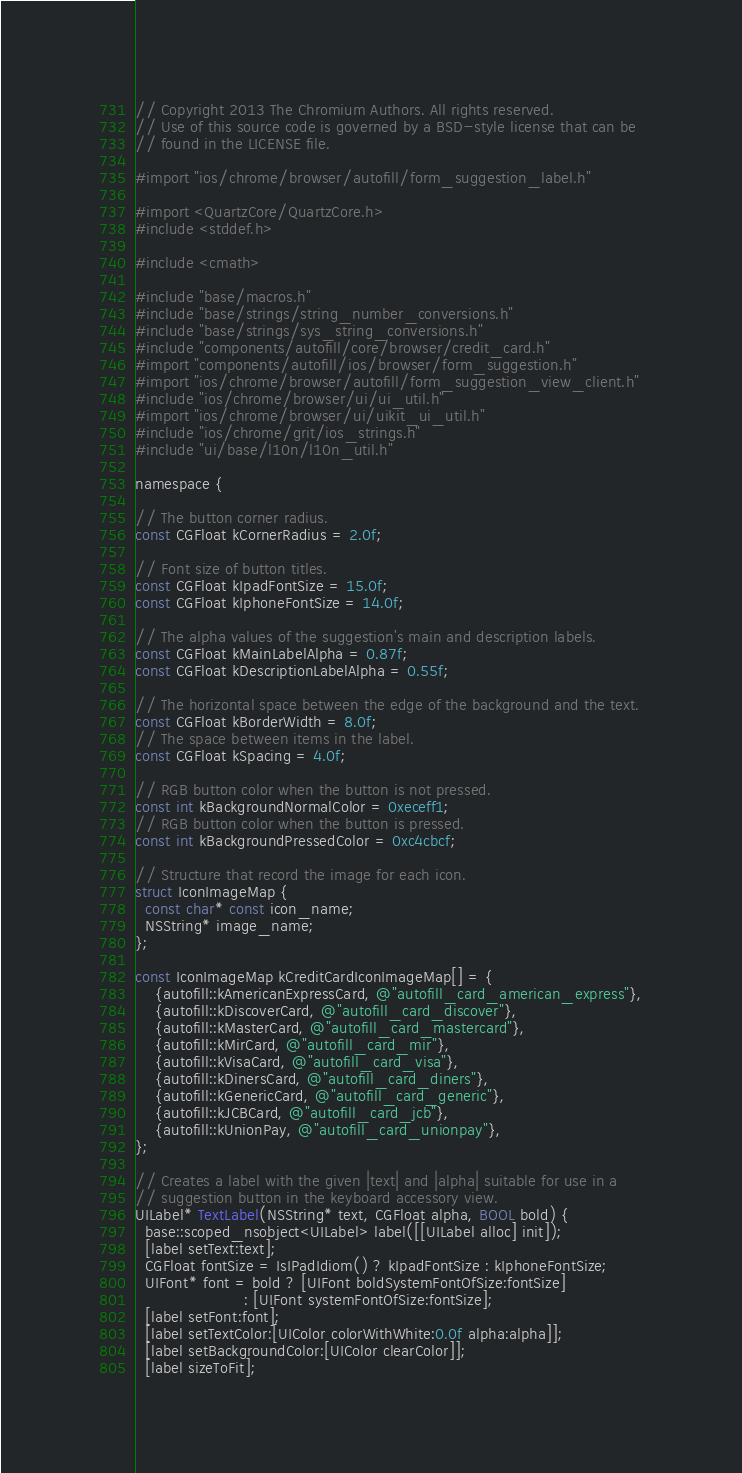<code> <loc_0><loc_0><loc_500><loc_500><_ObjectiveC_>// Copyright 2013 The Chromium Authors. All rights reserved.
// Use of this source code is governed by a BSD-style license that can be
// found in the LICENSE file.

#import "ios/chrome/browser/autofill/form_suggestion_label.h"

#import <QuartzCore/QuartzCore.h>
#include <stddef.h>

#include <cmath>

#include "base/macros.h"
#include "base/strings/string_number_conversions.h"
#include "base/strings/sys_string_conversions.h"
#include "components/autofill/core/browser/credit_card.h"
#import "components/autofill/ios/browser/form_suggestion.h"
#import "ios/chrome/browser/autofill/form_suggestion_view_client.h"
#include "ios/chrome/browser/ui/ui_util.h"
#import "ios/chrome/browser/ui/uikit_ui_util.h"
#include "ios/chrome/grit/ios_strings.h"
#include "ui/base/l10n/l10n_util.h"

namespace {

// The button corner radius.
const CGFloat kCornerRadius = 2.0f;

// Font size of button titles.
const CGFloat kIpadFontSize = 15.0f;
const CGFloat kIphoneFontSize = 14.0f;

// The alpha values of the suggestion's main and description labels.
const CGFloat kMainLabelAlpha = 0.87f;
const CGFloat kDescriptionLabelAlpha = 0.55f;

// The horizontal space between the edge of the background and the text.
const CGFloat kBorderWidth = 8.0f;
// The space between items in the label.
const CGFloat kSpacing = 4.0f;

// RGB button color when the button is not pressed.
const int kBackgroundNormalColor = 0xeceff1;
// RGB button color when the button is pressed.
const int kBackgroundPressedColor = 0xc4cbcf;

// Structure that record the image for each icon.
struct IconImageMap {
  const char* const icon_name;
  NSString* image_name;
};

const IconImageMap kCreditCardIconImageMap[] = {
    {autofill::kAmericanExpressCard, @"autofill_card_american_express"},
    {autofill::kDiscoverCard, @"autofill_card_discover"},
    {autofill::kMasterCard, @"autofill_card_mastercard"},
    {autofill::kMirCard, @"autofill_card_mir"},
    {autofill::kVisaCard, @"autofill_card_visa"},
    {autofill::kDinersCard, @"autofill_card_diners"},
    {autofill::kGenericCard, @"autofill_card_generic"},
    {autofill::kJCBCard, @"autofill_card_jcb"},
    {autofill::kUnionPay, @"autofill_card_unionpay"},
};

// Creates a label with the given |text| and |alpha| suitable for use in a
// suggestion button in the keyboard accessory view.
UILabel* TextLabel(NSString* text, CGFloat alpha, BOOL bold) {
  base::scoped_nsobject<UILabel> label([[UILabel alloc] init]);
  [label setText:text];
  CGFloat fontSize = IsIPadIdiom() ? kIpadFontSize : kIphoneFontSize;
  UIFont* font = bold ? [UIFont boldSystemFontOfSize:fontSize]
                      : [UIFont systemFontOfSize:fontSize];
  [label setFont:font];
  [label setTextColor:[UIColor colorWithWhite:0.0f alpha:alpha]];
  [label setBackgroundColor:[UIColor clearColor]];
  [label sizeToFit];</code> 